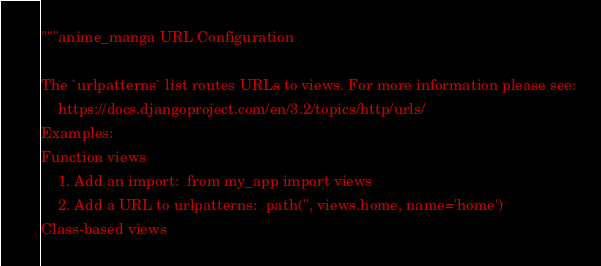Convert code to text. <code><loc_0><loc_0><loc_500><loc_500><_Python_>"""anime_manga URL Configuration

The `urlpatterns` list routes URLs to views. For more information please see:
    https://docs.djangoproject.com/en/3.2/topics/http/urls/
Examples:
Function views
    1. Add an import:  from my_app import views
    2. Add a URL to urlpatterns:  path('', views.home, name='home')
Class-based views</code> 